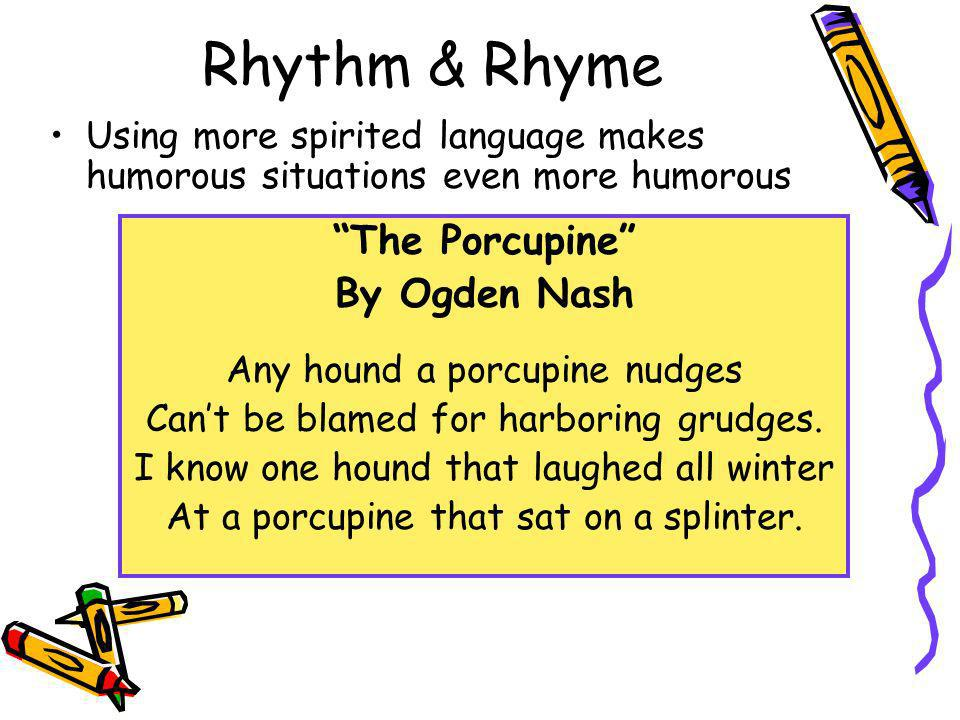What other literary techniques might enhance the presentation of this poem? Apart from rhyme, employing literary devices like irony, hyperbole, and onomatopoeia could enhance the comic effect. Irony could be introduced through contradictory situations that end unexpectedly, hyperbole could exaggerate the scenarios to absurd levels, and onomatopoeia could make the interaction between the hound and the porcupine more vivid and amusing. These techniques would add layers of humor and help deepen the reader's engagement with the poem. 